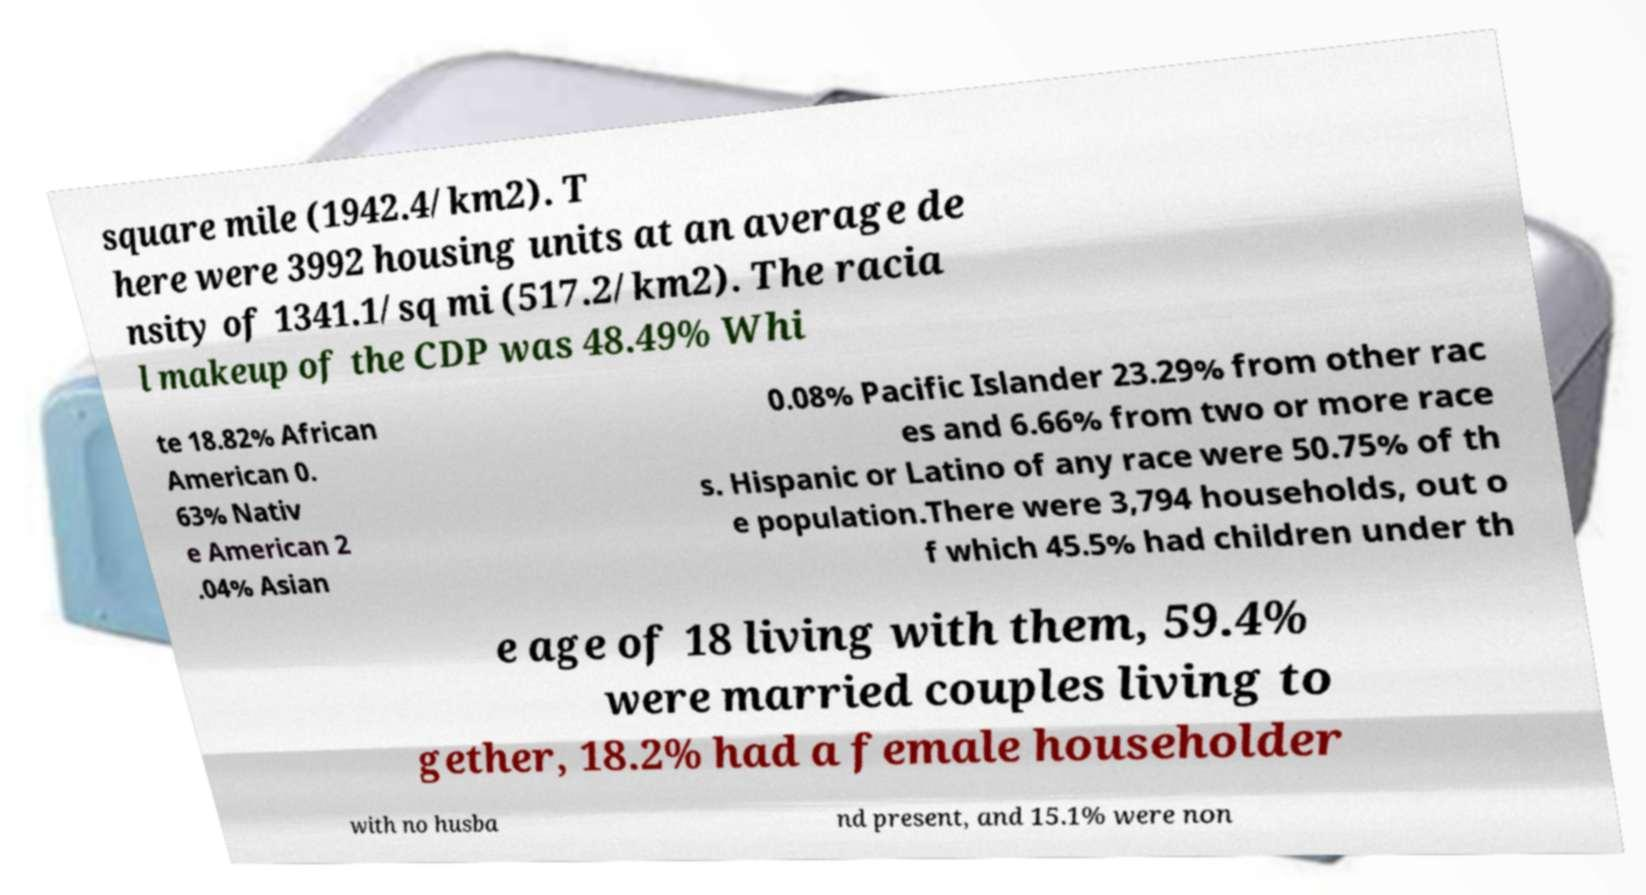Please read and relay the text visible in this image. What does it say? square mile (1942.4/km2). T here were 3992 housing units at an average de nsity of 1341.1/sq mi (517.2/km2). The racia l makeup of the CDP was 48.49% Whi te 18.82% African American 0. 63% Nativ e American 2 .04% Asian 0.08% Pacific Islander 23.29% from other rac es and 6.66% from two or more race s. Hispanic or Latino of any race were 50.75% of th e population.There were 3,794 households, out o f which 45.5% had children under th e age of 18 living with them, 59.4% were married couples living to gether, 18.2% had a female householder with no husba nd present, and 15.1% were non 